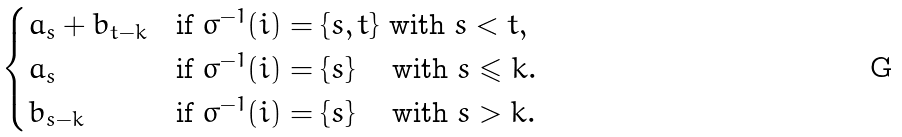Convert formula to latex. <formula><loc_0><loc_0><loc_500><loc_500>\begin{cases} a _ { s } + b _ { t - k } & \text {if } \sigma ^ { - 1 } ( i ) = \{ s , t \} \text { with } s < t , \\ a _ { s } & \text {if } \sigma ^ { - 1 } ( i ) = \{ s \} \quad \text { with } s \leqslant k . \\ b _ { s - k } & \text {if } \sigma ^ { - 1 } ( i ) = \{ s \} \quad \text { with } s > k . \\ \end{cases}</formula> 